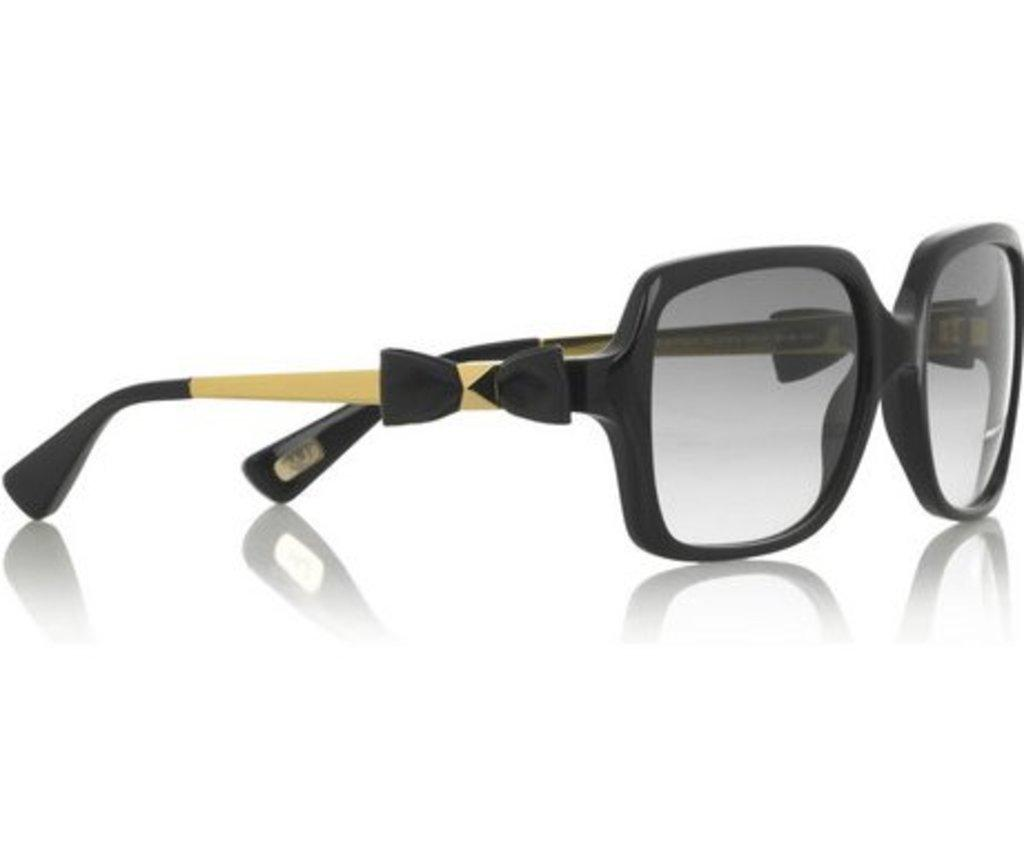What object can be seen in the image? There are sunglasses in the image. Is there any indication of the sunglasses' reflection in the image? Yes, there is a reflection of the sunglasses at the bottom of the image. What color is the background of the image? The background of the image is white in color. What type of advertisement is displayed on the sunglasses in the image? There is no advertisement displayed on the sunglasses in the image; they are simply sunglasses. Can you see a goose or a gun in the image? No, there is no goose or gun present in the image. 